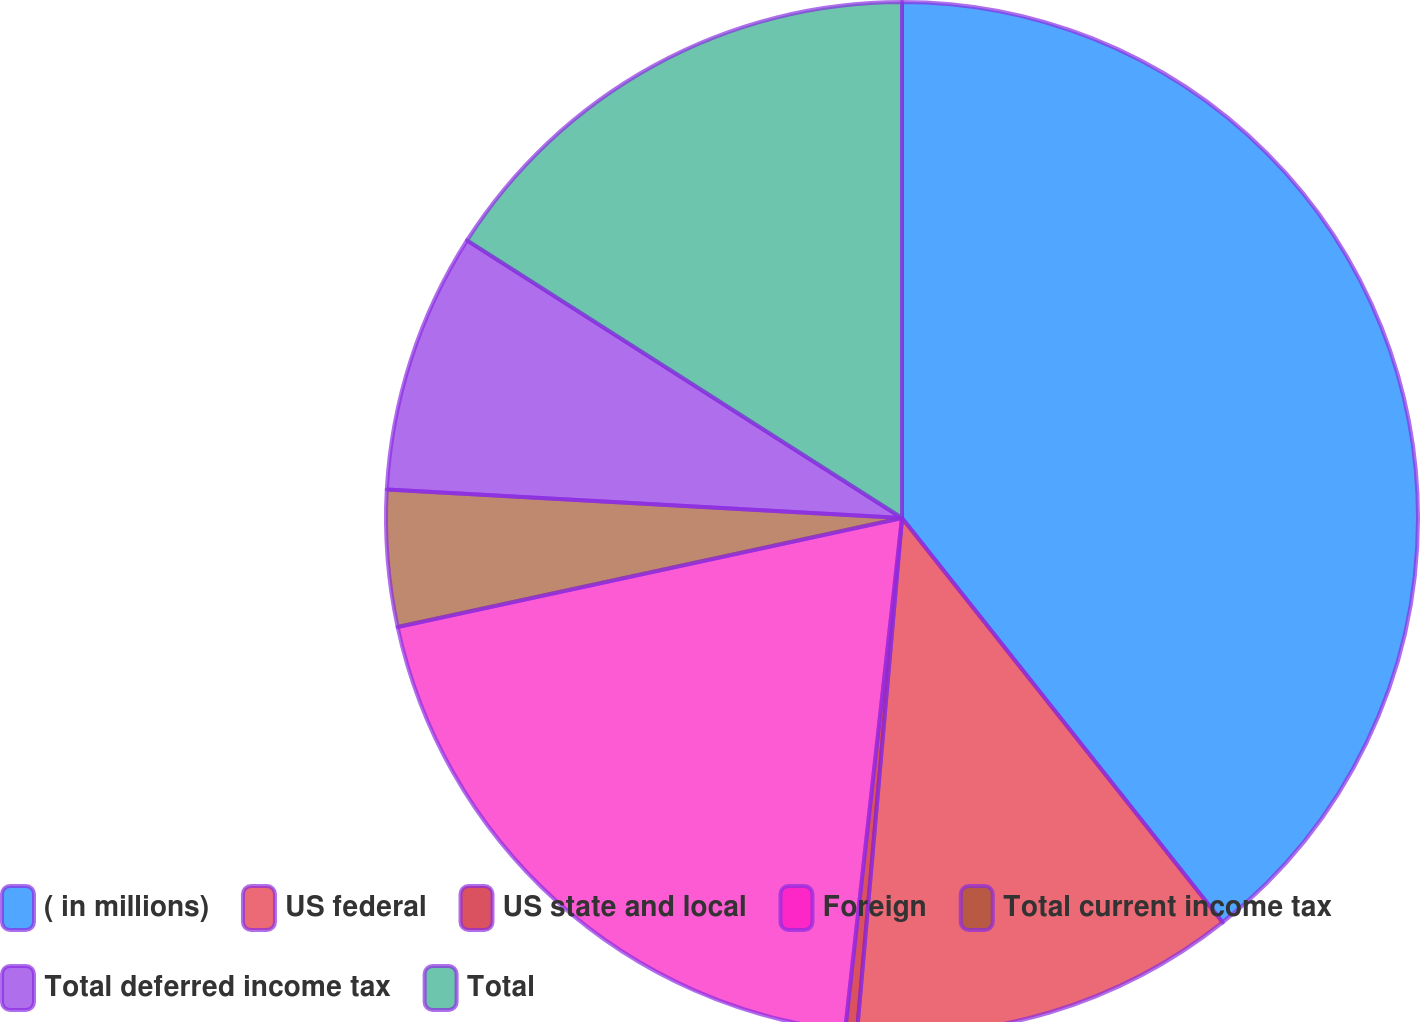Convert chart. <chart><loc_0><loc_0><loc_500><loc_500><pie_chart><fcel>( in millions)<fcel>US federal<fcel>US state and local<fcel>Foreign<fcel>Total current income tax<fcel>Total deferred income tax<fcel>Total<nl><fcel>39.33%<fcel>12.06%<fcel>0.37%<fcel>19.85%<fcel>4.27%<fcel>8.16%<fcel>15.96%<nl></chart> 